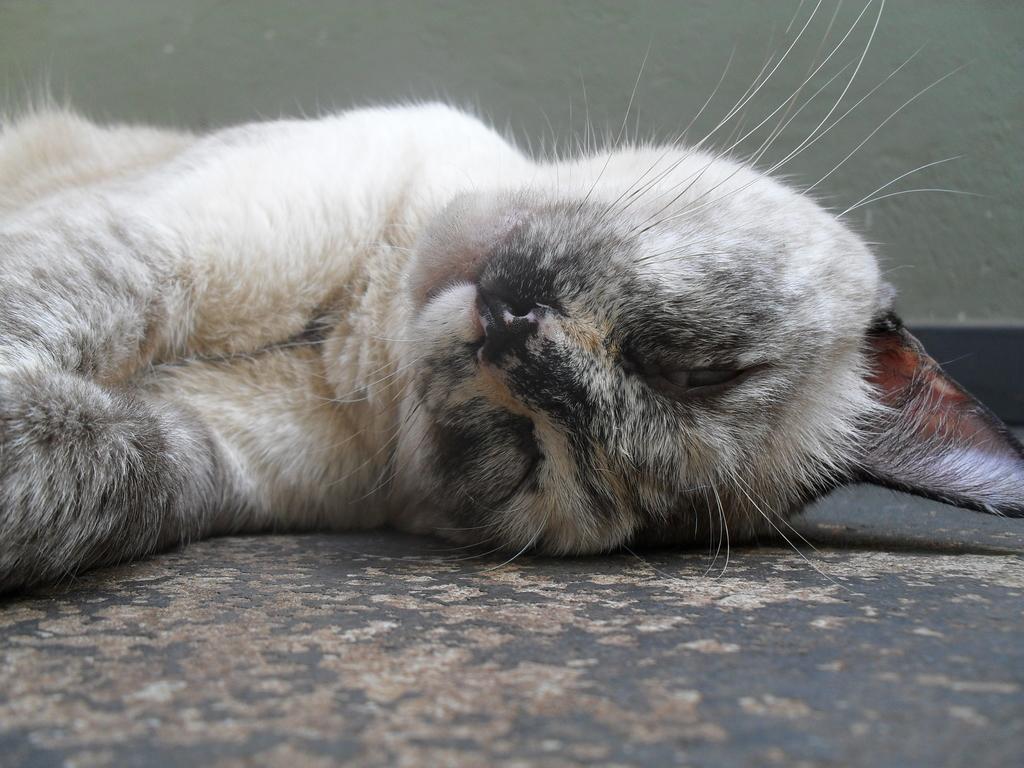Could you give a brief overview of what you see in this image? In this image we can see a cat on the floor and wall in the background. 